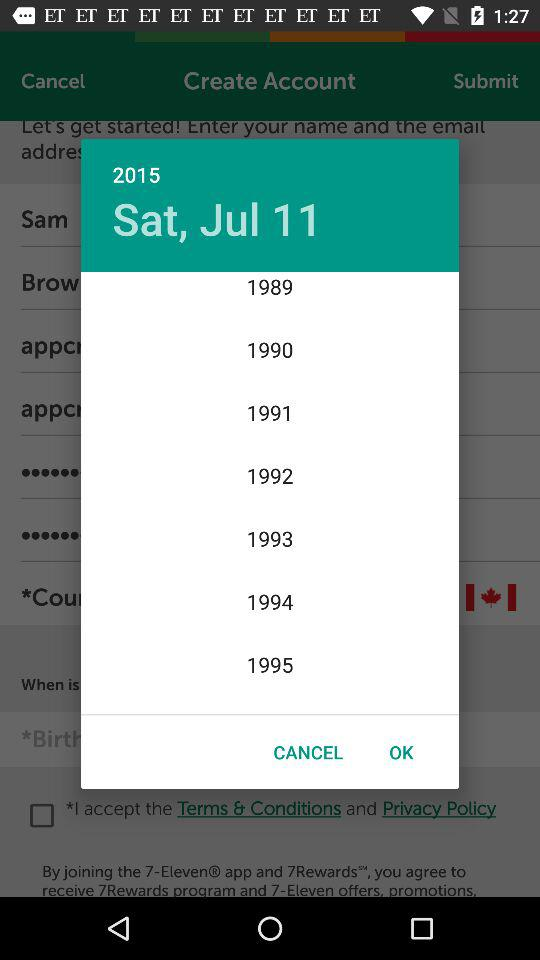What is the day on July 11, 2015? The day is Saturday. 